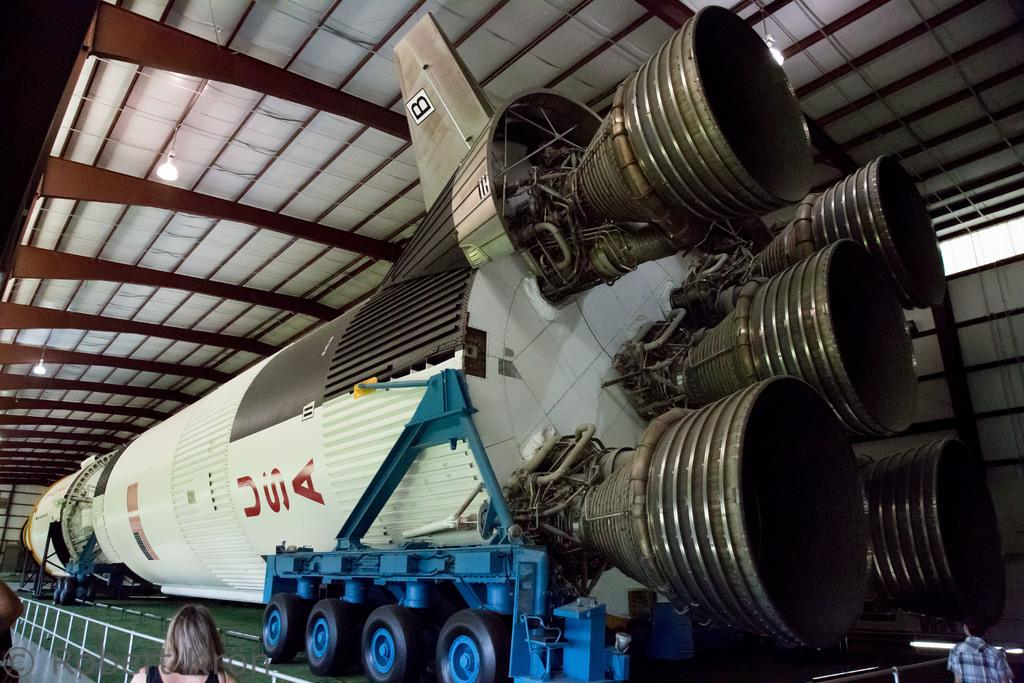Provide a one-sentence caption for the provided image. A rocket with USA on it sits ready to launch. 